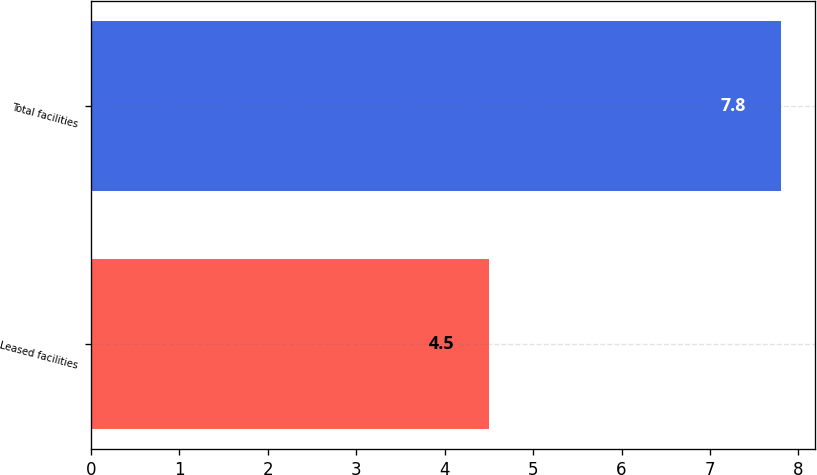Convert chart. <chart><loc_0><loc_0><loc_500><loc_500><bar_chart><fcel>Leased facilities<fcel>Total facilities<nl><fcel>4.5<fcel>7.8<nl></chart> 